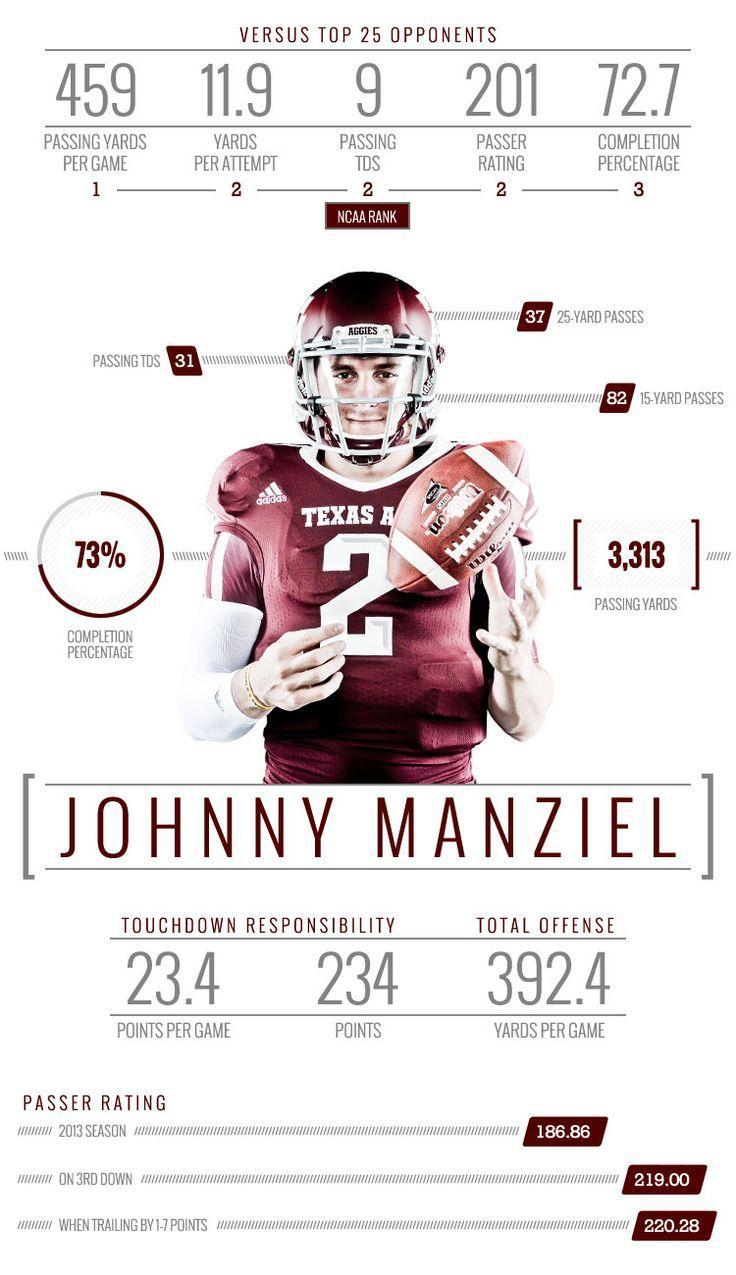What is the number written in the player's jersey?
Answer the question with a short phrase. 2 